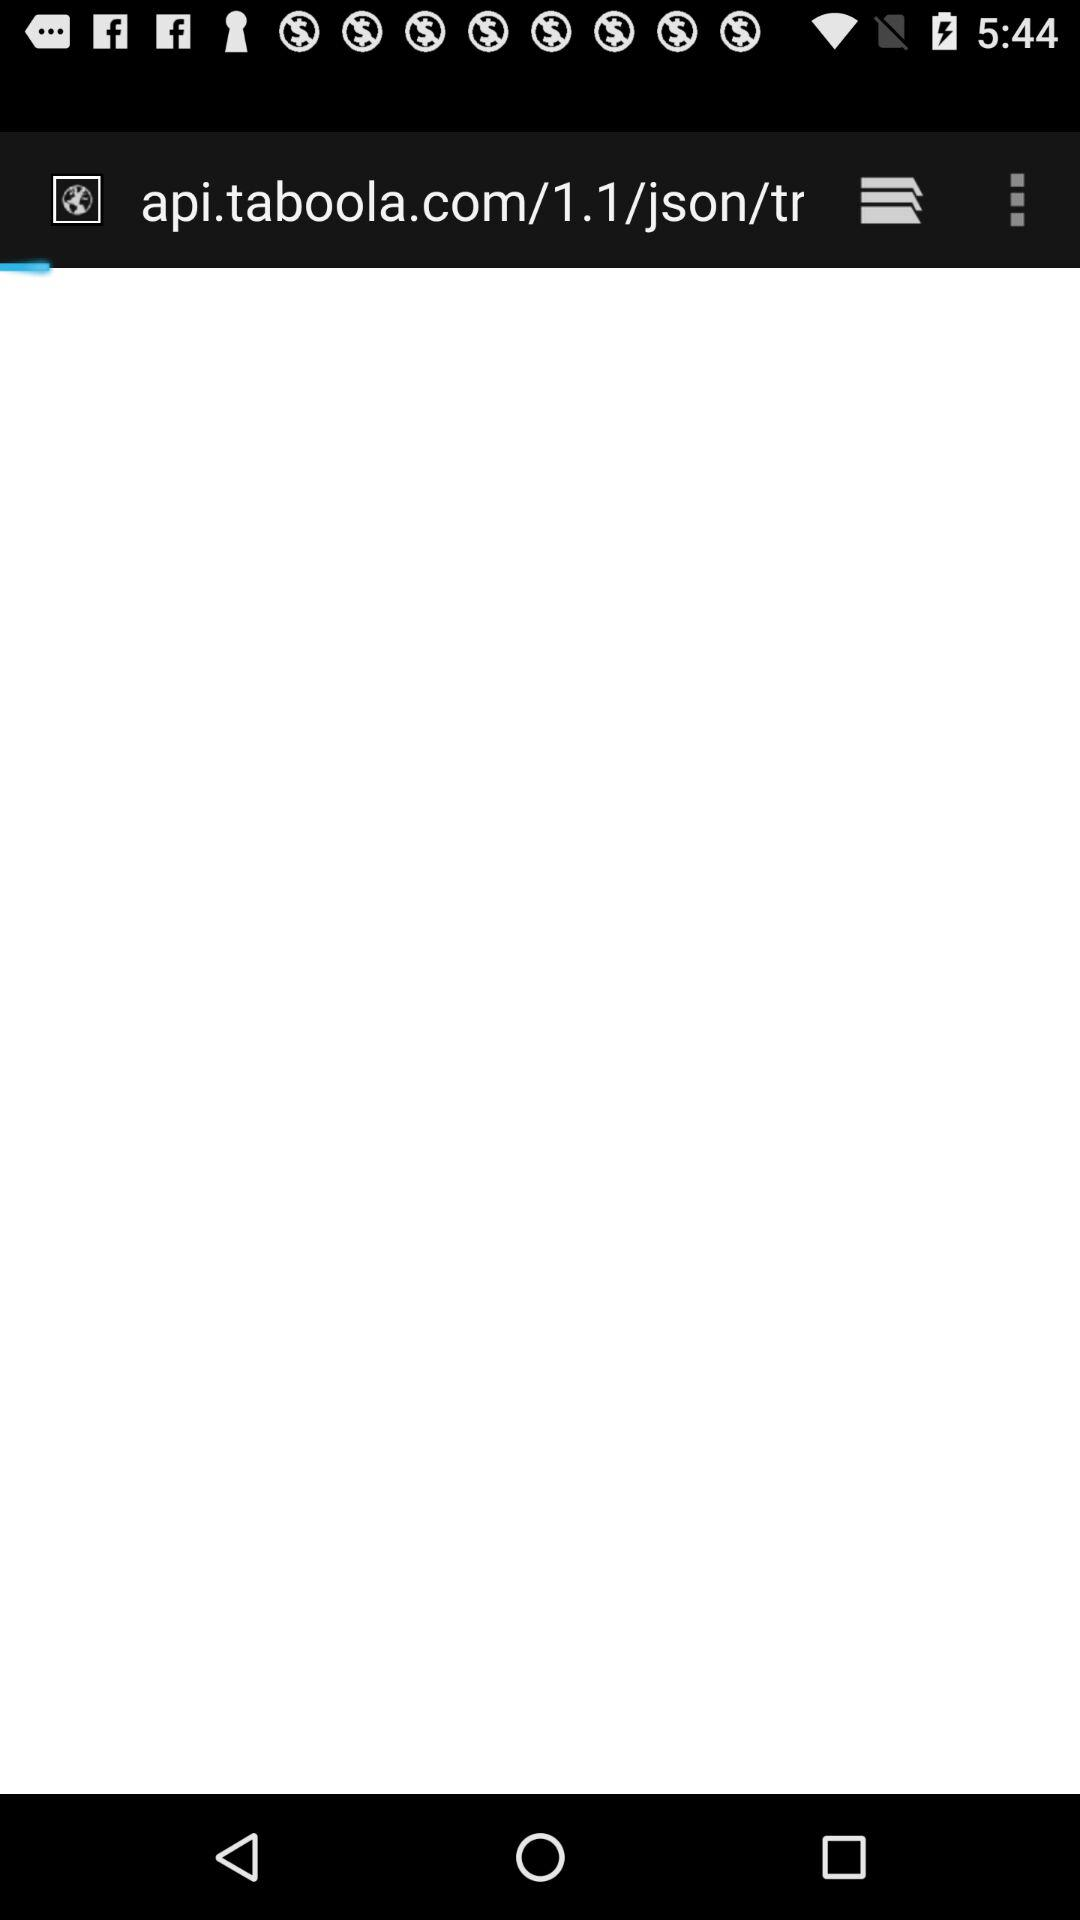What is the application name? The application name is "WGN9NEWS". 